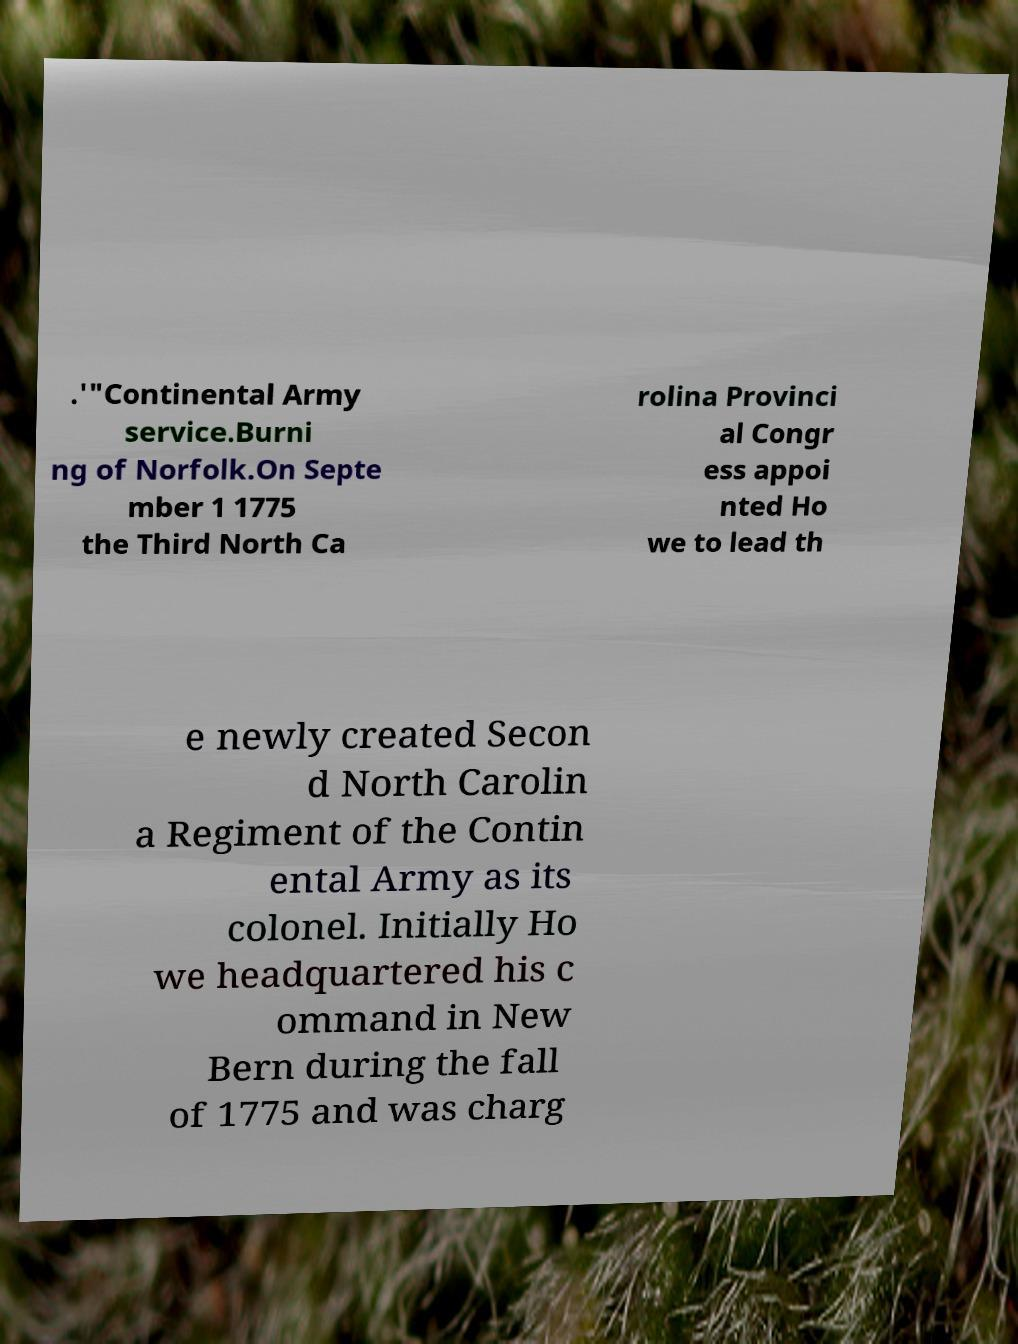What messages or text are displayed in this image? I need them in a readable, typed format. .'"Continental Army service.Burni ng of Norfolk.On Septe mber 1 1775 the Third North Ca rolina Provinci al Congr ess appoi nted Ho we to lead th e newly created Secon d North Carolin a Regiment of the Contin ental Army as its colonel. Initially Ho we headquartered his c ommand in New Bern during the fall of 1775 and was charg 